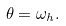Convert formula to latex. <formula><loc_0><loc_0><loc_500><loc_500>\theta = \omega _ { h } .</formula> 